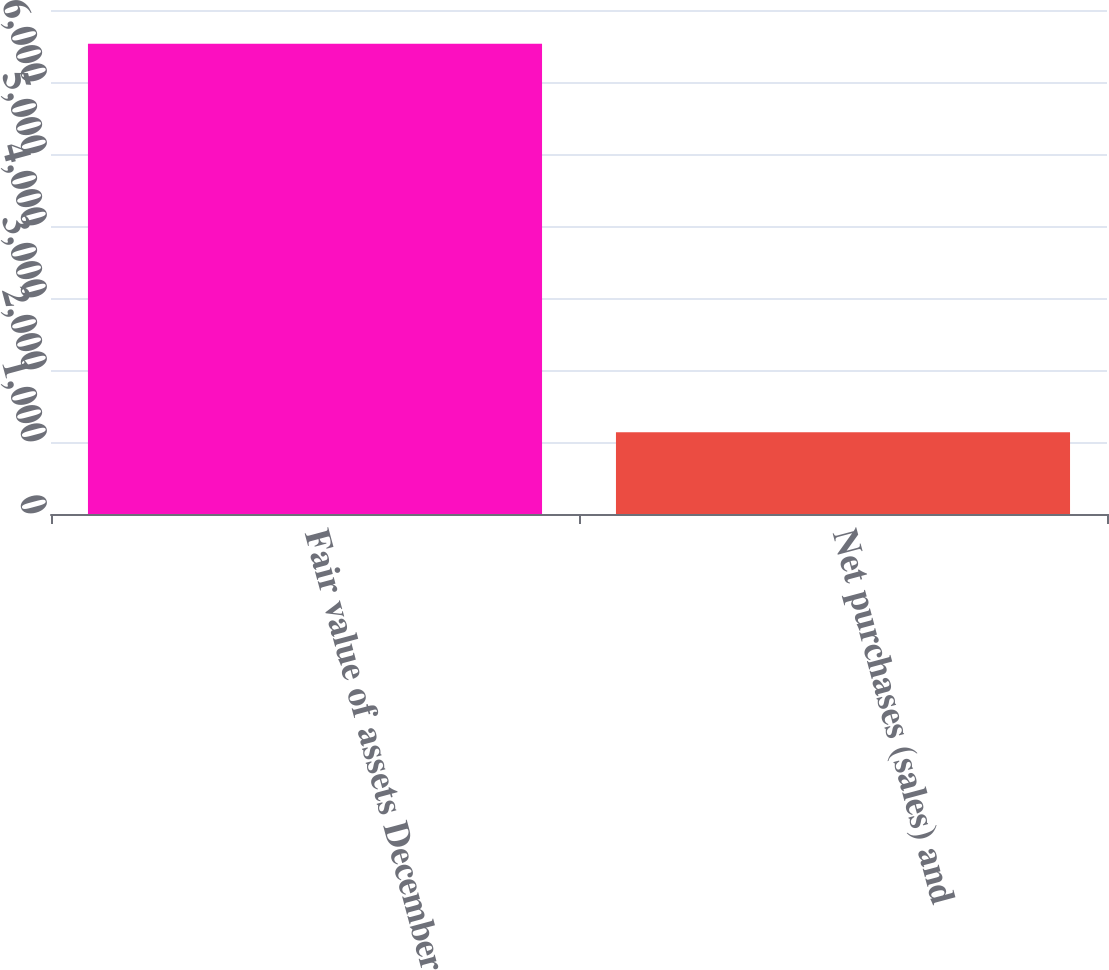Convert chart. <chart><loc_0><loc_0><loc_500><loc_500><bar_chart><fcel>Fair value of assets December<fcel>Net purchases (sales) and<nl><fcel>6531<fcel>1136<nl></chart> 